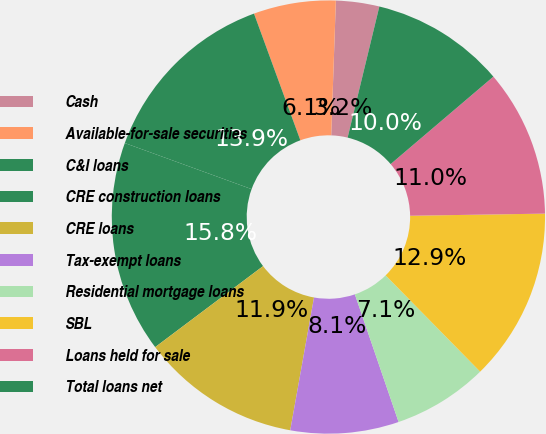Convert chart to OTSL. <chart><loc_0><loc_0><loc_500><loc_500><pie_chart><fcel>Cash<fcel>Available-for-sale securities<fcel>C&I loans<fcel>CRE construction loans<fcel>CRE loans<fcel>Tax-exempt loans<fcel>Residential mortgage loans<fcel>SBL<fcel>Loans held for sale<fcel>Total loans net<nl><fcel>3.23%<fcel>6.13%<fcel>13.87%<fcel>15.8%<fcel>11.93%<fcel>8.07%<fcel>7.1%<fcel>12.9%<fcel>10.97%<fcel>10.0%<nl></chart> 